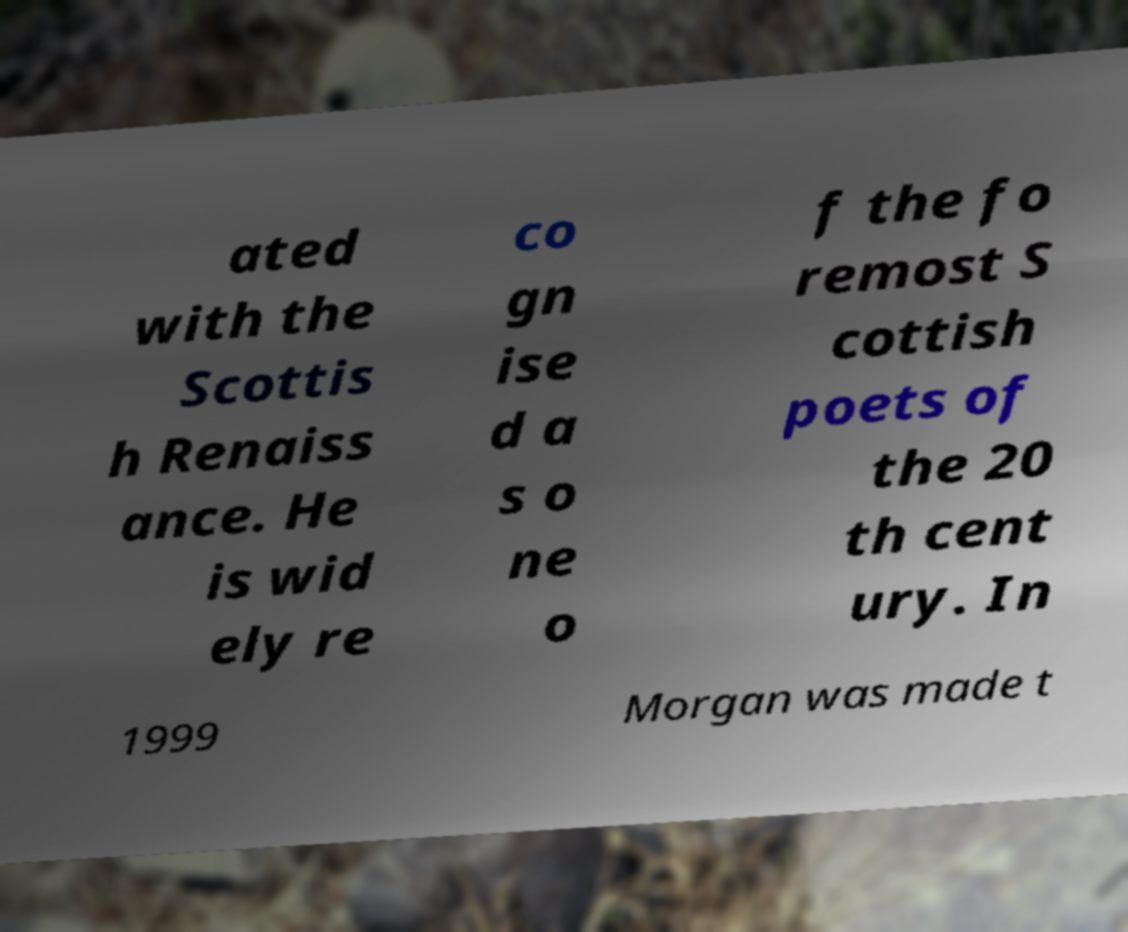Could you assist in decoding the text presented in this image and type it out clearly? ated with the Scottis h Renaiss ance. He is wid ely re co gn ise d a s o ne o f the fo remost S cottish poets of the 20 th cent ury. In 1999 Morgan was made t 